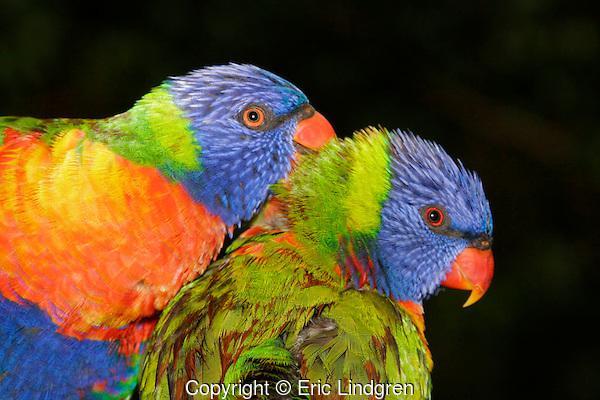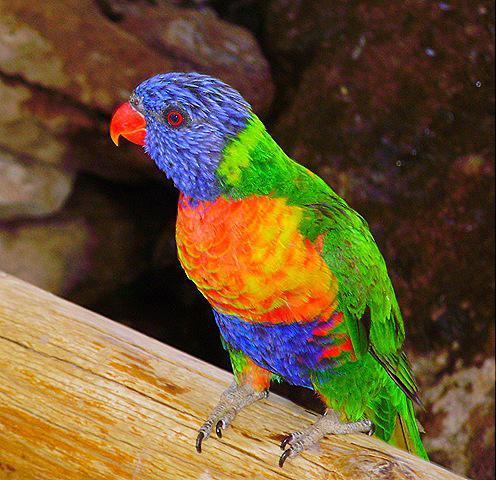The first image is the image on the left, the second image is the image on the right. For the images shown, is this caption "All of the images contain at least two parrots." true? Answer yes or no. No. 